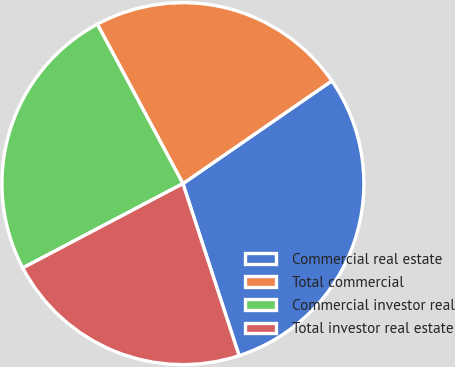<chart> <loc_0><loc_0><loc_500><loc_500><pie_chart><fcel>Commercial real estate<fcel>Total commercial<fcel>Commercial investor real<fcel>Total investor real estate<nl><fcel>29.59%<fcel>23.22%<fcel>24.87%<fcel>22.31%<nl></chart> 